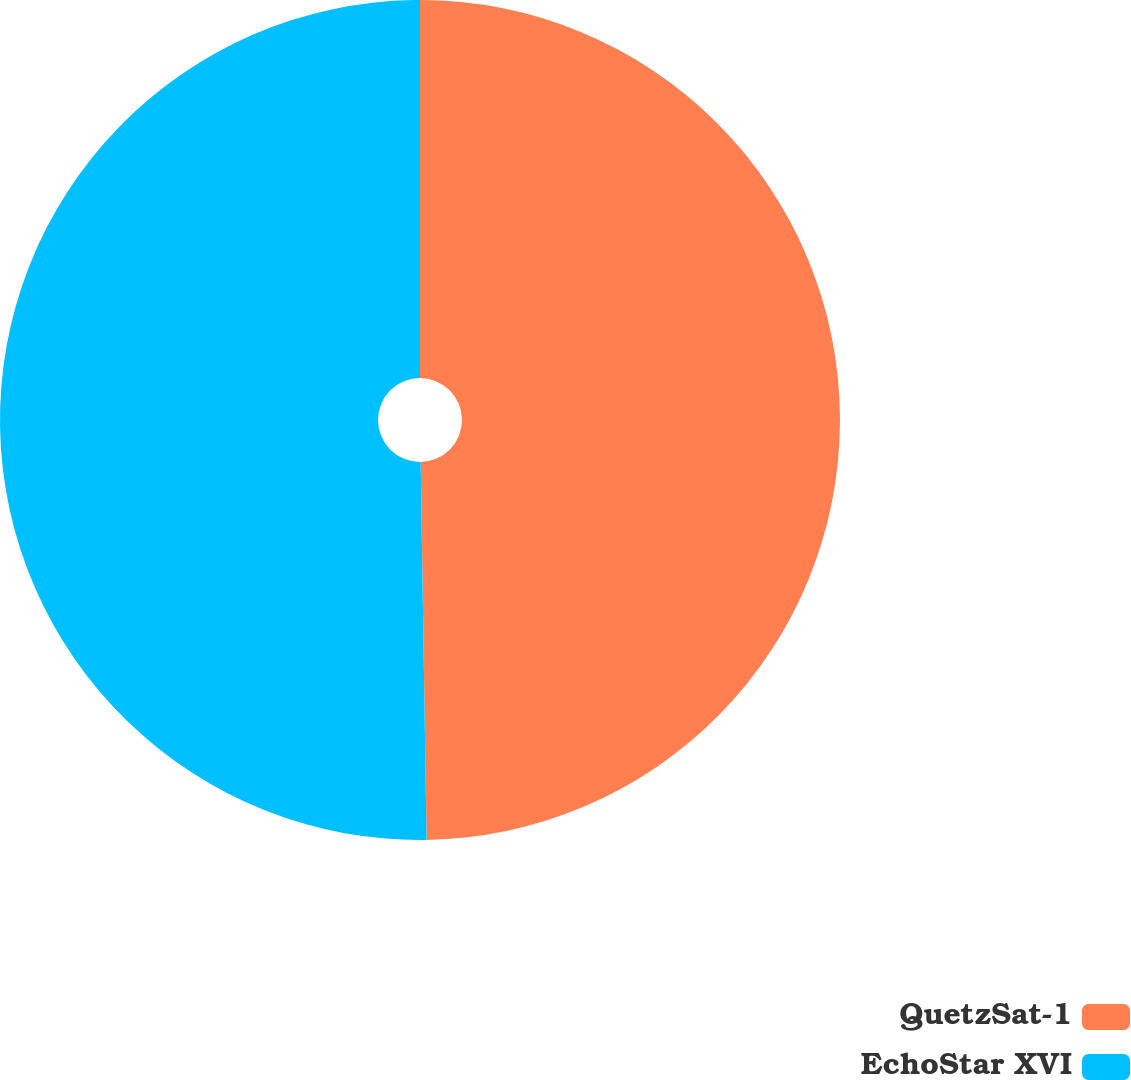<chart> <loc_0><loc_0><loc_500><loc_500><pie_chart><fcel>QuetzSat-1<fcel>EchoStar XVI<nl><fcel>49.75%<fcel>50.25%<nl></chart> 